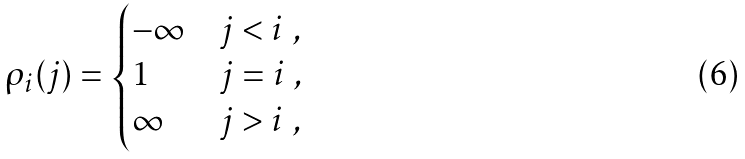<formula> <loc_0><loc_0><loc_500><loc_500>\rho _ { i } ( j ) = \begin{cases} - \infty & j < i \ , \\ 1 & j = i \ , \\ \infty & j > i \ , \end{cases}</formula> 